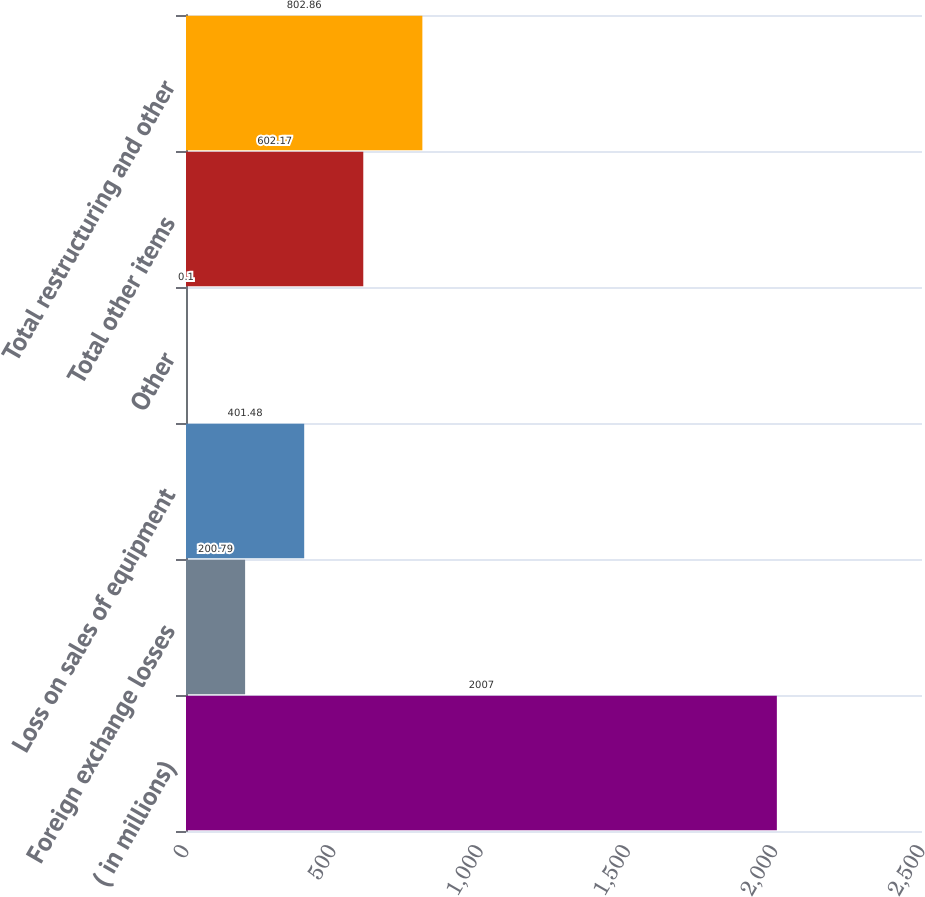<chart> <loc_0><loc_0><loc_500><loc_500><bar_chart><fcel>( in millions)<fcel>Foreign exchange losses<fcel>Loss on sales of equipment<fcel>Other<fcel>Total other items<fcel>Total restructuring and other<nl><fcel>2007<fcel>200.79<fcel>401.48<fcel>0.1<fcel>602.17<fcel>802.86<nl></chart> 